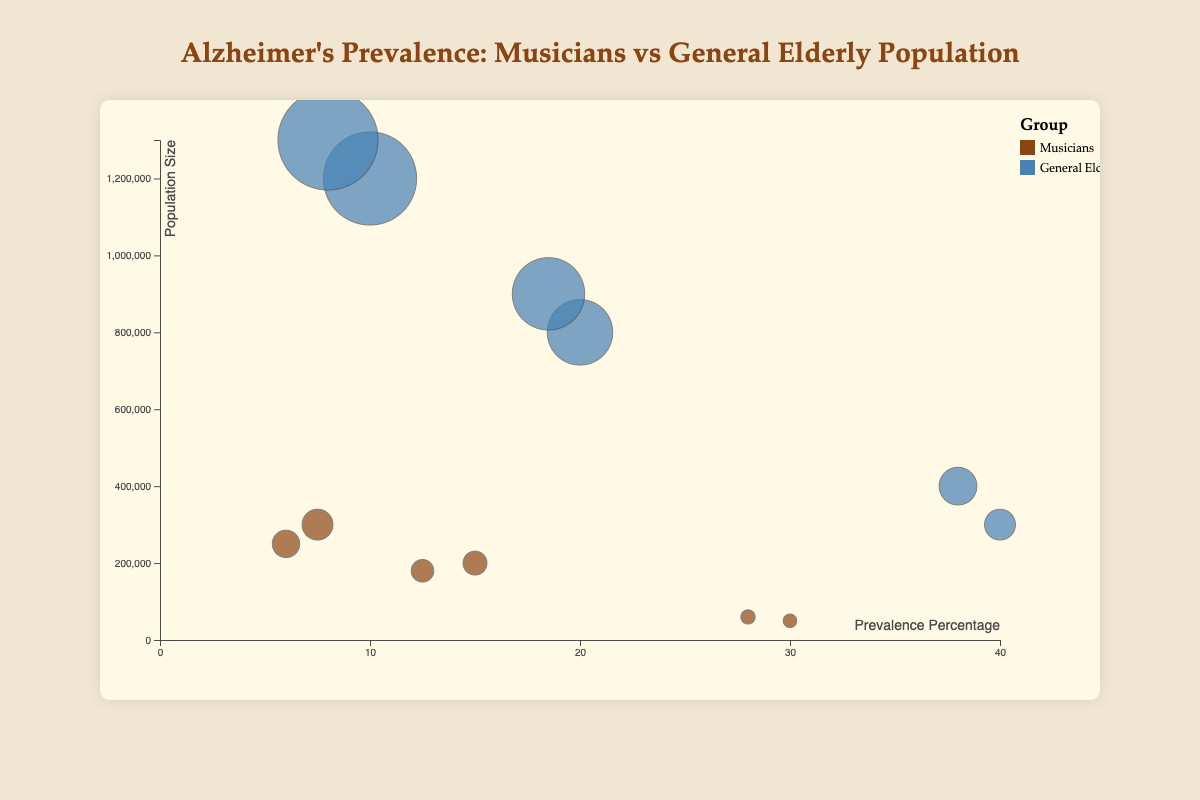What does the title of this chart say? The title is a text element located at the top of the figure. It reads "Alzheimer's Prevalence: Musicians vs General Elderly Population."
Answer: Alzheimer's Prevalence: Musicians vs General Elderly Population How many bubbles represent musicians aged 85+? The bubbles can be identified by the color representing the "Musicians" group and the age range "85+." Two bubbles fit this description: one for males and one for females.
Answer: 2 Which group has a higher prevalence percentage in the 75-84 age range for females? To find this, compare the bubbles for females aged 75-84 in both groups. The prevalence percentage for musicians is 12.5%, whereas for the general elderly population, it is 18.5%.
Answer: General Elderly Population What is the largest population size among males in the 65-74 age range? By comparing the population sizes for the male groups aged 65-74, the general elderly population has a size of 1,200,000, while musicians have a population size of 300,000.
Answer: 1,200,000 How many age ranges show a higher Alzheimer's prevalence in the general elderly population compared to musicians? Compare the prevalence percentages in each age range (65-74, 75-84, 85+) for both groups. 
65-74: General (10.0%) > Musicians (7.5% and 6.0%); 
75-84: General (20.0% and 18.5%) > Musicians (15.0% and 12.5%); 
85+: General (40.0% and 38.0%) > Musicians (30.0% and 28.0%). 
Thus, all three age ranges show higher prevalence in the general elderly population.
Answer: 3 Which gender among musicians aged 85+ has the smallest bubble? To determine this, compare the bubbles for males and females aged 85+ among musicians. Both have relatively small bubbles, representing population sizes of 50,000 (males) and 60,000 (females). Males have the smaller bubble.
Answer: Male By how many percentage points does the Alzheimer's prevalence for males aged 75-84 differ between musicians and the general elderly population? The prevalence for males aged 75-84 is 15.0% for musicians and 20.0% for the general elderly population. The difference is 20.0% - 15.0% = 5.0 percentage points.
Answer: 5.0 What is the ratio of the population size between male and female musicians aged 65-74? The population size of male musicians aged 65-74 is 300,000, and for female musicians, it is 250,000. The ratio is 300,000 / 250,000 = 1.2.
Answer: 1.2 How many bubbles represent the general elderly population? There are six bubbles representing the general elderly population, covering all combinations of gender (male and female) and age ranges (65-74, 75-84, 85+).
Answer: 6 In which age range do musicians show the largest increase in Alzheimer's prevalence as they age? Look at the three age ranges for musicians and observe the prevalence increase: 
65-74: 6.0%-7.5%, 
75-84: 12.5%-15.0%, 
85+: 28.0%-30.0%. 
The largest increase happens from 75-84 to 85+, where the prevalence goes up significantly.
Answer: 75-84 to 85+ 